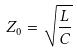Convert formula to latex. <formula><loc_0><loc_0><loc_500><loc_500>Z _ { 0 } = \sqrt { \frac { L } { C } }</formula> 